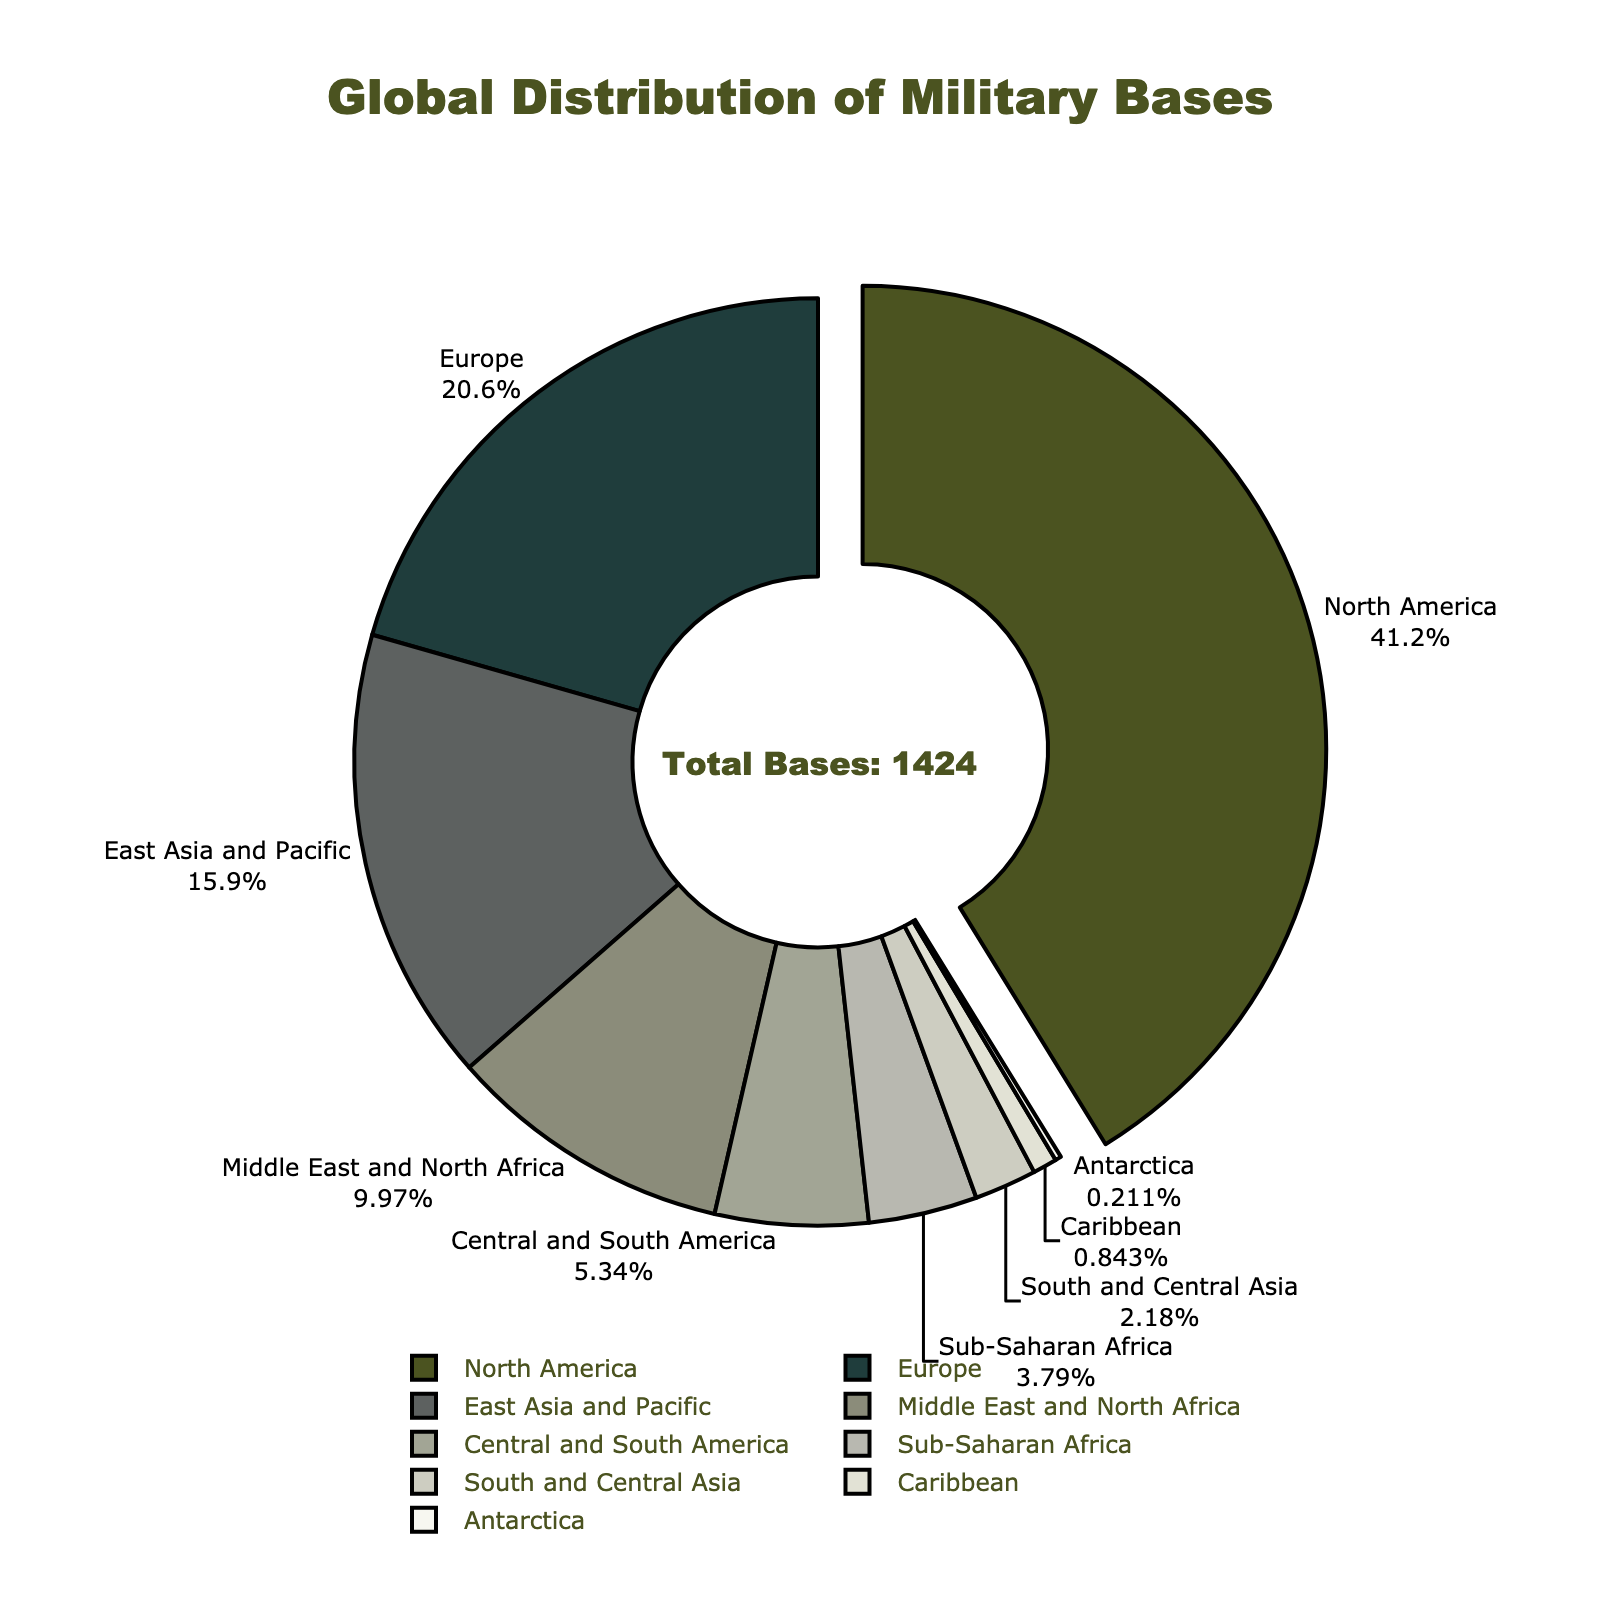which region has the highest number of military bases? North America has the highest number because the segment representing North America is the largest and pulled out of the pie chart to indicate the maximum value.
Answer: North America what percentage of military bases are located in Europe? The pie chart segment for Europe shows both the label "Europe" and the percentage of the total number of military bases.
Answer: 22.93% how many more military bases are in north America compared to Europe? North America has 587 bases, and Europe has 293. The difference is calculated as 587 - 293.
Answer: 294 which region has the smallest number of military bases? The pie chart shows the smallest segment is for Antarctica.
Answer: Antarctica what is the total number of military bases in East Asia and the Pacific, Middle East and North Africa, and Central and South America combined? Sum the number of bases in East Asia and Pacific (226), Middle East and North Africa (142), and Central and South America (76). The calculation is 226 + 142 + 76.
Answer: 444 how do the number of bases in sub-Saharan Africa compare to those in South and Central Asia? Both segments for Sub-Saharan Africa and South and Central Asia are shown but with different sizes. Sub-Saharan Africa has 54 while South and Central Asia has 31.
Answer: Sub-Saharan Africa has more which regions have fewer than 100 military bases? The pie chart segments for Central and South America, Sub-Saharan Africa, South and Central Asia, the Caribbean, and Antarctica have fewer than 100 military bases.
Answer: Central and South America, Sub-Saharan Africa, South and Central Asia, Caribbean, Antarctica what fraction of the total military bases is found in the Caribbean? The pie chart shows the number of military bases in the Caribbean as 12. Divide by the total military bases which are 1424. Fraction = 12/1424.
Answer: 1/118 